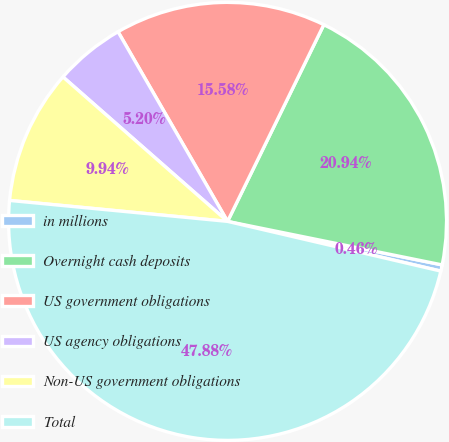Convert chart to OTSL. <chart><loc_0><loc_0><loc_500><loc_500><pie_chart><fcel>in millions<fcel>Overnight cash deposits<fcel>US government obligations<fcel>US agency obligations<fcel>Non-US government obligations<fcel>Total<nl><fcel>0.46%<fcel>20.94%<fcel>15.58%<fcel>5.2%<fcel>9.94%<fcel>47.88%<nl></chart> 